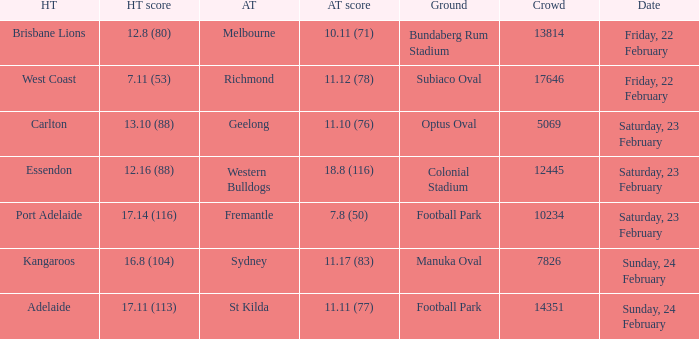Where the home team scored 13.10 (88), what was the size of the crowd? 5069.0. 